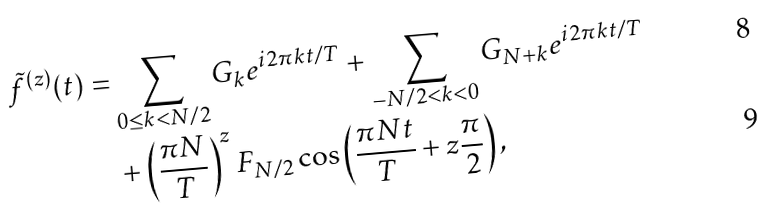<formula> <loc_0><loc_0><loc_500><loc_500>\tilde { f } ^ { ( z ) } ( t ) = & \sum _ { 0 \leq k < N / 2 } G _ { k } e ^ { i 2 \pi k t / T } + \sum _ { - N / 2 < k < 0 } G _ { N + k } e ^ { i 2 \pi k t / T } \\ & + \left ( \frac { \pi N } { T } \right ) ^ { z } F _ { N / 2 } \cos \left ( \frac { \pi N t } { T } + z \frac { \pi } { 2 } \right ) ,</formula> 